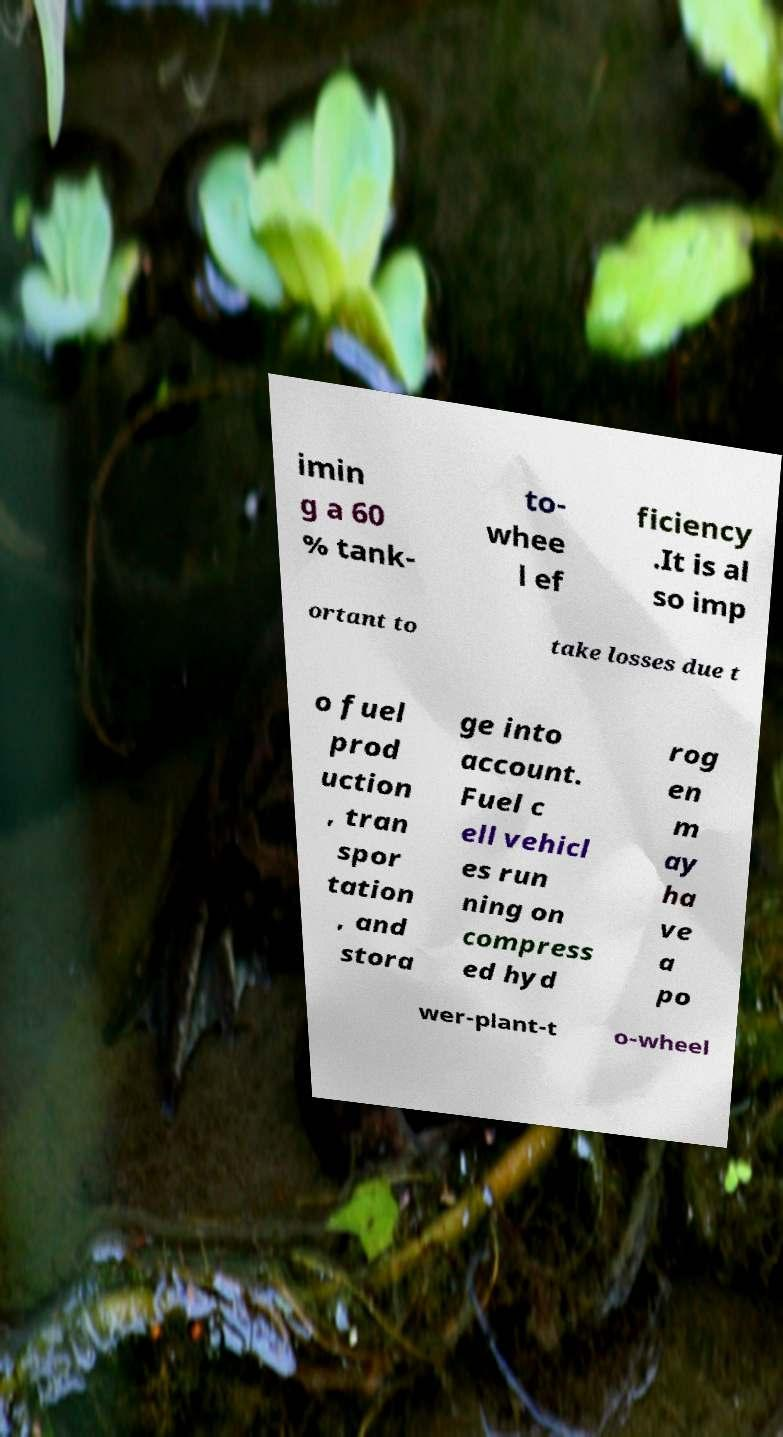Please read and relay the text visible in this image. What does it say? imin g a 60 % tank- to- whee l ef ficiency .It is al so imp ortant to take losses due t o fuel prod uction , tran spor tation , and stora ge into account. Fuel c ell vehicl es run ning on compress ed hyd rog en m ay ha ve a po wer-plant-t o-wheel 